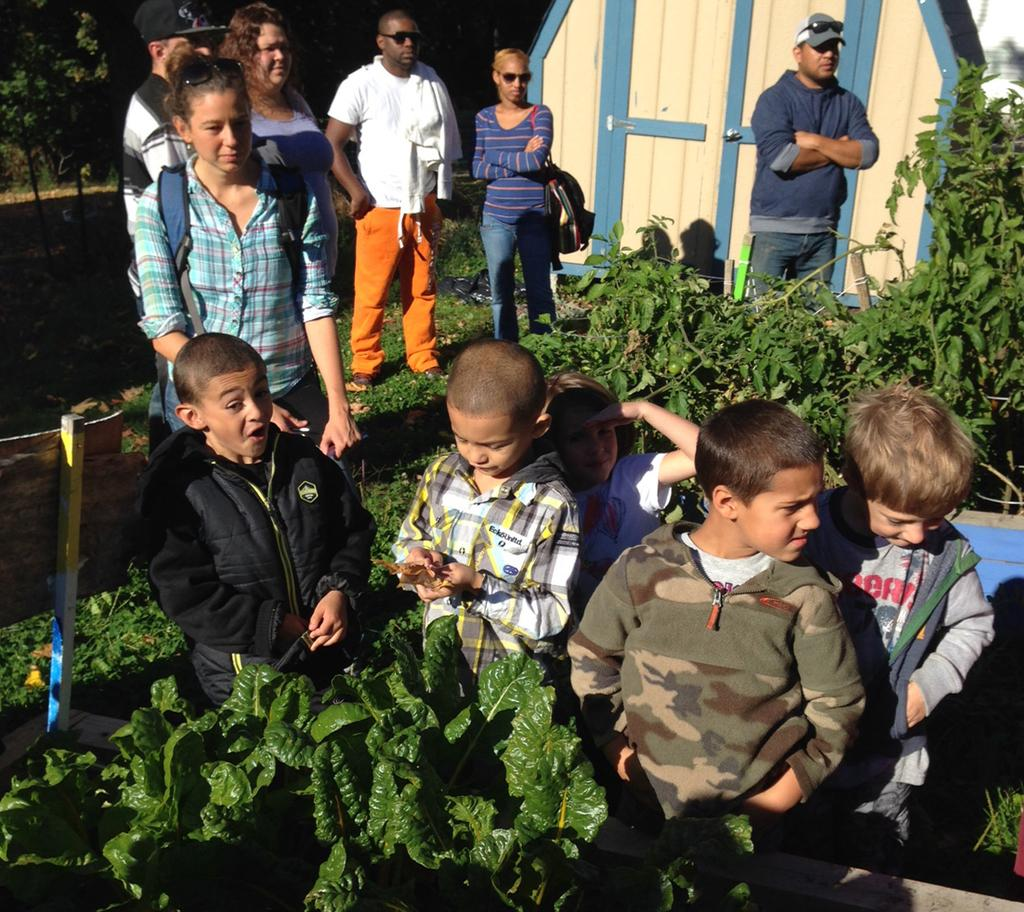How many groups of people can be seen in the image? There are groups of people in the image, but the exact number cannot be determined without more specific information. Where are the people standing in the image? The people are standing on the surface of the grass in the image. What type of structure is present in the image? There is a wooden house in the image. What type of vegetation is visible in the image? There are plants and trees in the image. What type of rake is being used to maintain the system in the image? There is no rake or system present in the image; it features groups of people, a wooden house, plants, and trees. 